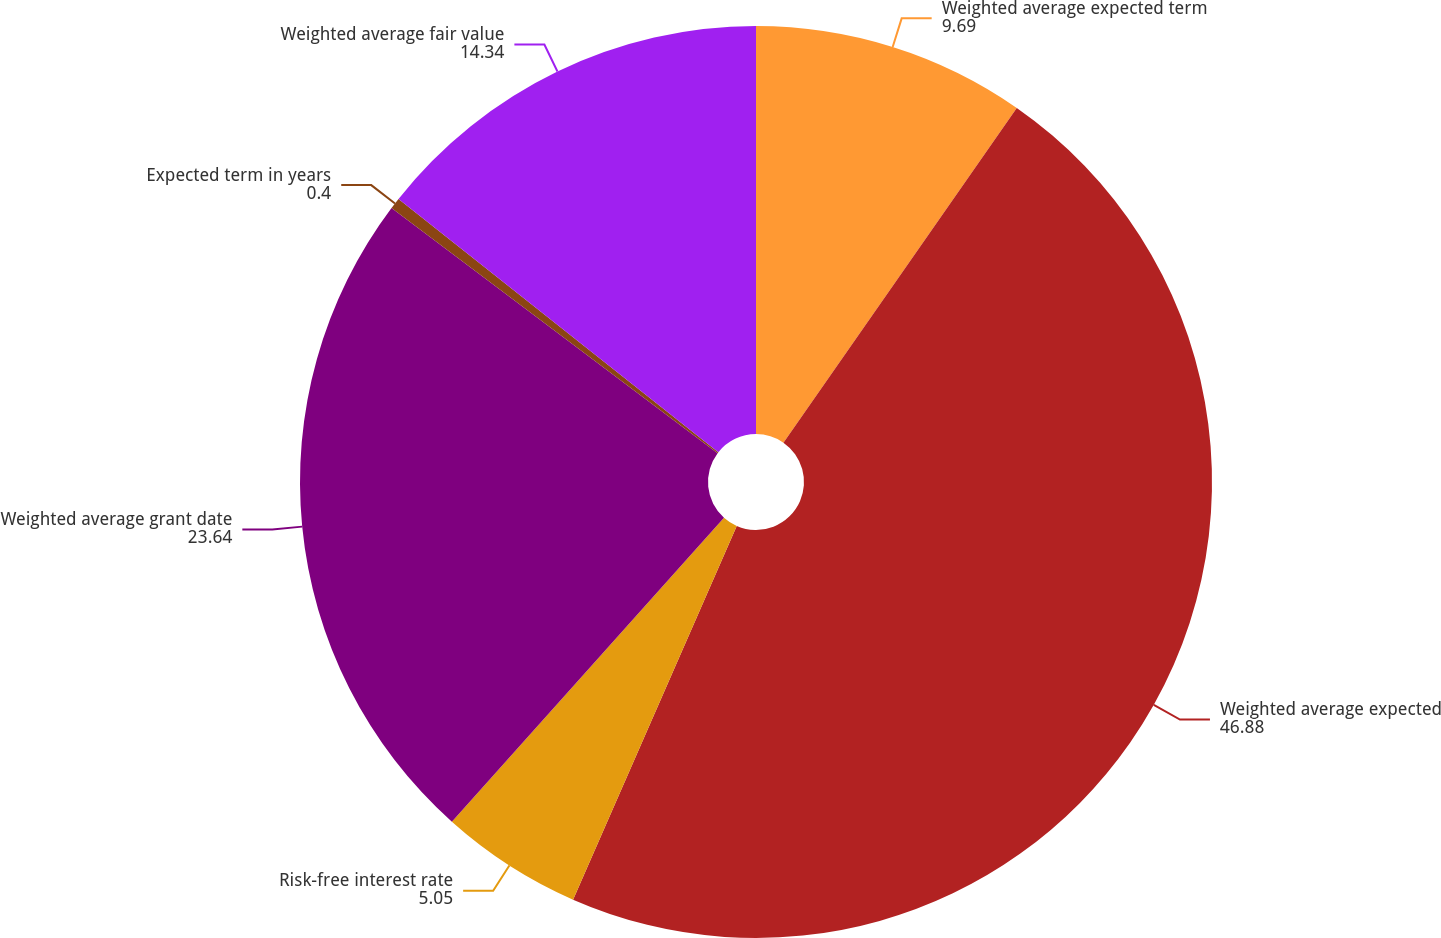Convert chart to OTSL. <chart><loc_0><loc_0><loc_500><loc_500><pie_chart><fcel>Weighted average expected term<fcel>Weighted average expected<fcel>Risk-free interest rate<fcel>Weighted average grant date<fcel>Expected term in years<fcel>Weighted average fair value<nl><fcel>9.69%<fcel>46.88%<fcel>5.05%<fcel>23.64%<fcel>0.4%<fcel>14.34%<nl></chart> 